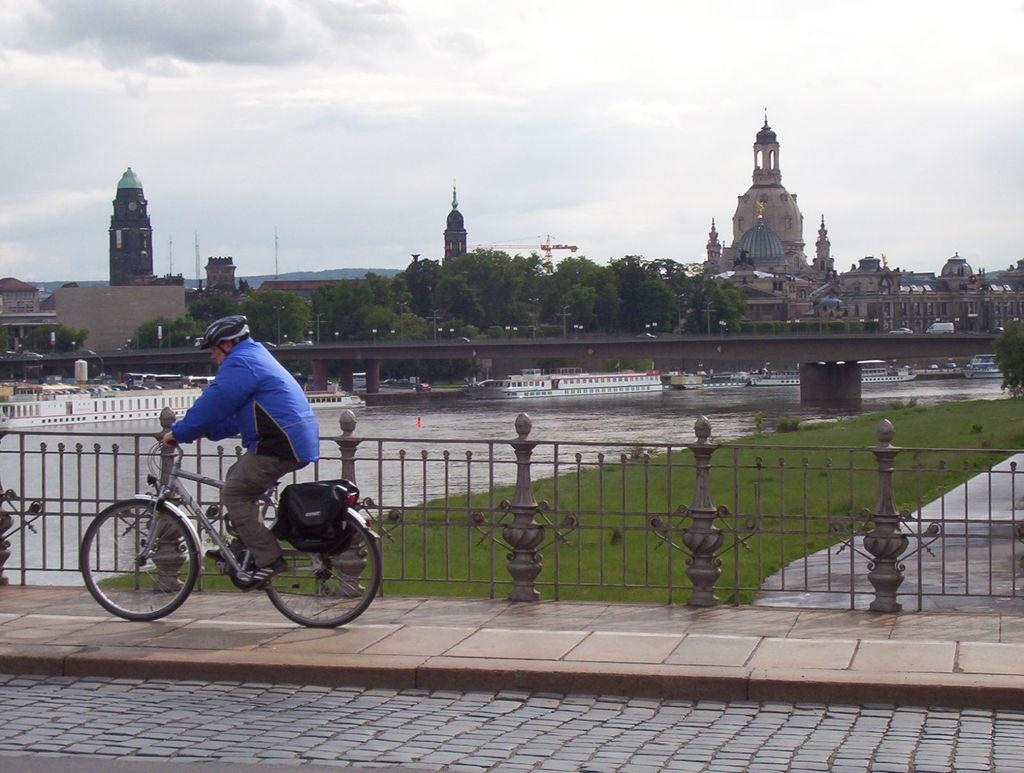What is the person in the image wearing on their head? The person is wearing a black helmet. What color is the jacket the person is wearing? The person is wearing a blue jacket. What activity is the person engaged in? The person is riding a bicycle. What type of terrain can be seen in the image? There is a river, grass, and trees in the image. What structures are visible in the background? There is a bridge and buildings in the background. What type of cheese is being used to build the bridge in the background? There is no cheese present in the image, and the bridge is not being built. 